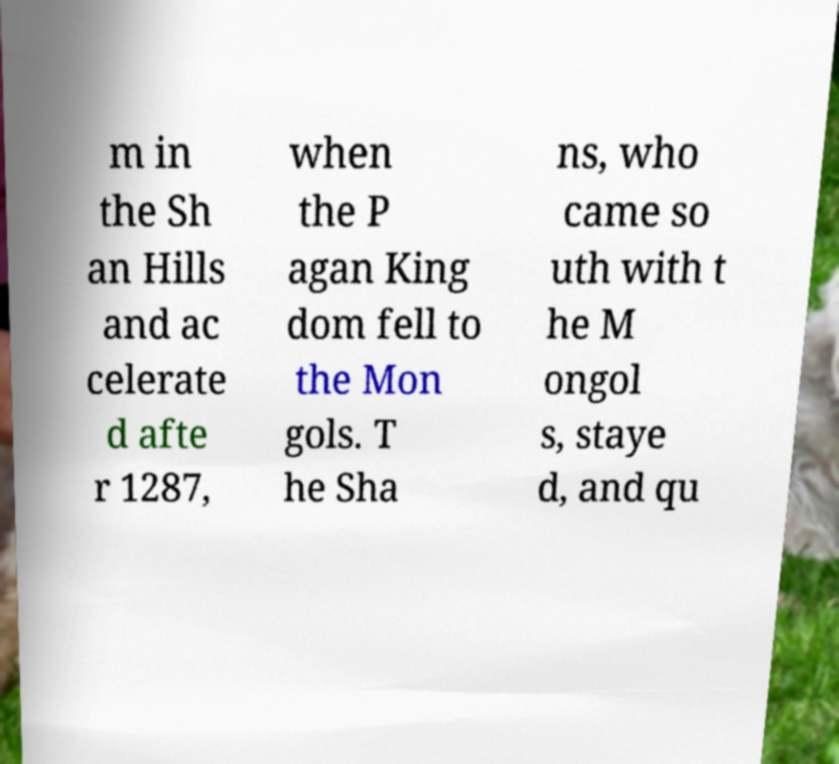Can you read and provide the text displayed in the image?This photo seems to have some interesting text. Can you extract and type it out for me? m in the Sh an Hills and ac celerate d afte r 1287, when the P agan King dom fell to the Mon gols. T he Sha ns, who came so uth with t he M ongol s, staye d, and qu 